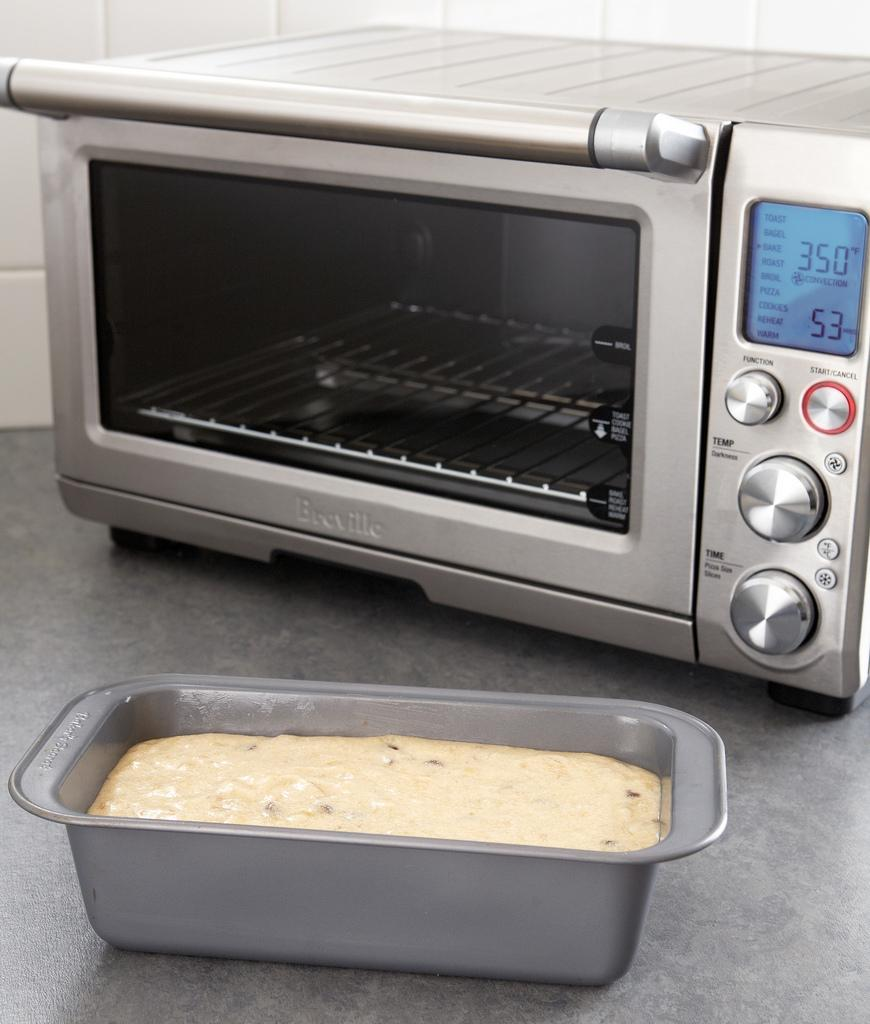<image>
Relay a brief, clear account of the picture shown. A pan of an uncooked dish sits in front of a Breville toaster oven. 